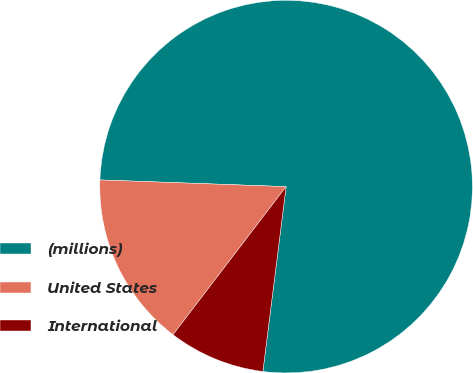Convert chart to OTSL. <chart><loc_0><loc_0><loc_500><loc_500><pie_chart><fcel>(millions)<fcel>United States<fcel>International<nl><fcel>76.41%<fcel>15.19%<fcel>8.39%<nl></chart> 